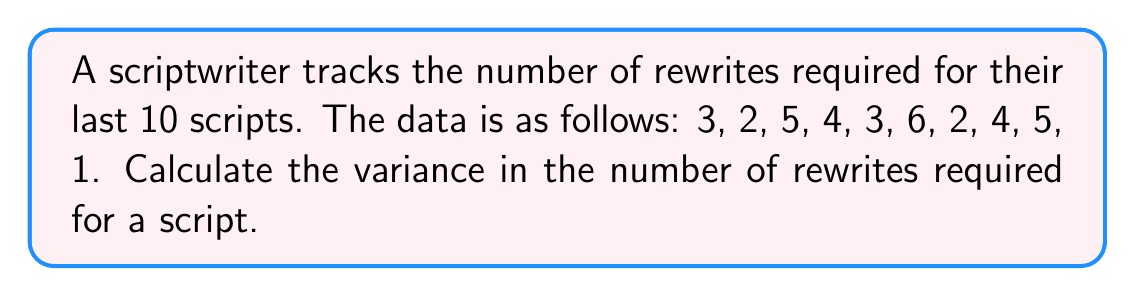Show me your answer to this math problem. To calculate the variance, we'll follow these steps:

1. Calculate the mean (μ) of the dataset:
   $$ \mu = \frac{3 + 2 + 5 + 4 + 3 + 6 + 2 + 4 + 5 + 1}{10} = \frac{35}{10} = 3.5 $$

2. Calculate the squared differences from the mean:
   $$ (3 - 3.5)^2 = 0.25 $$
   $$ (2 - 3.5)^2 = 2.25 $$
   $$ (5 - 3.5)^2 = 2.25 $$
   $$ (4 - 3.5)^2 = 0.25 $$
   $$ (3 - 3.5)^2 = 0.25 $$
   $$ (6 - 3.5)^2 = 6.25 $$
   $$ (2 - 3.5)^2 = 2.25 $$
   $$ (4 - 3.5)^2 = 0.25 $$
   $$ (5 - 3.5)^2 = 2.25 $$
   $$ (1 - 3.5)^2 = 6.25 $$

3. Sum the squared differences:
   $$ 0.25 + 2.25 + 2.25 + 0.25 + 0.25 + 6.25 + 2.25 + 0.25 + 2.25 + 6.25 = 22.5 $$

4. Divide the sum by the number of data points (n) to get the variance:
   $$ \text{Variance} = \frac{22.5}{10} = 2.25 $$

Thus, the variance in the number of rewrites required for a script is 2.25.
Answer: 2.25 